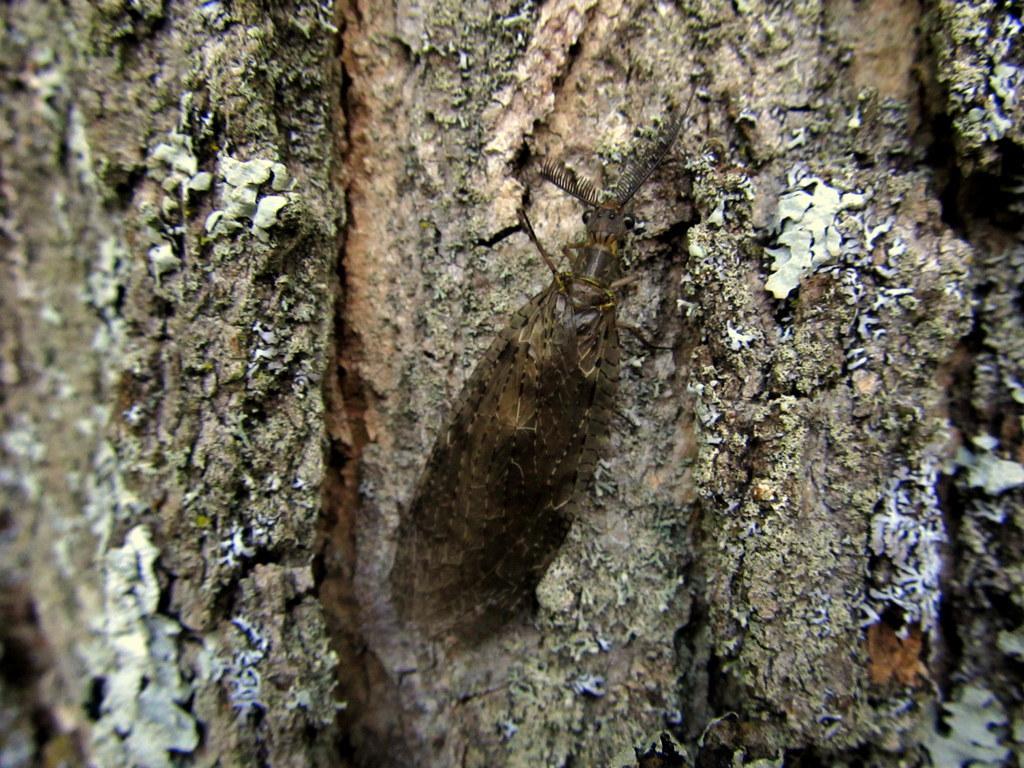In one or two sentences, can you explain what this image depicts? In this image there is an insect on the trunk of a tree. 